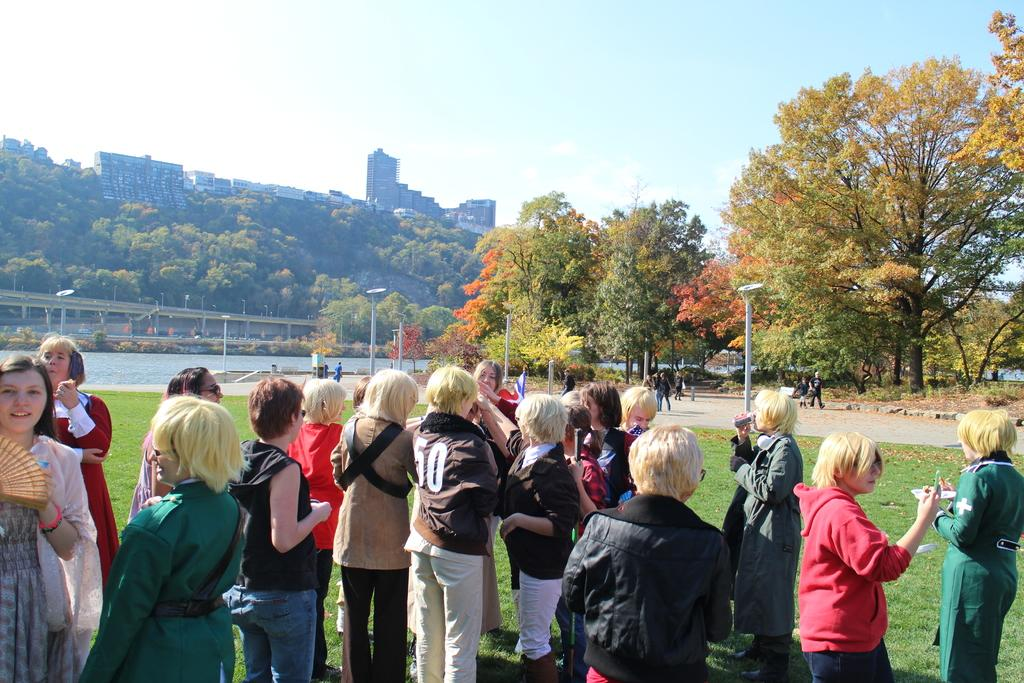How many people are in the image? There are people in the image, but the exact number is not specified. What type of terrain is visible in the image? There is grass visible in the image. What type of structures are present in the image? There are lights on poles in the image. What type of natural elements are present in the image? There are trees in the image. What can be seen in the background of the image? In the background, there is water visible, a bridge, more trees, plants, buildings, and the sky. What type of stew is being served at the picnic in the image? There is no picnic or stew present in the image. What scientific theory is being discussed by the people in the image? There is no indication of a scientific discussion or theory in the image. 